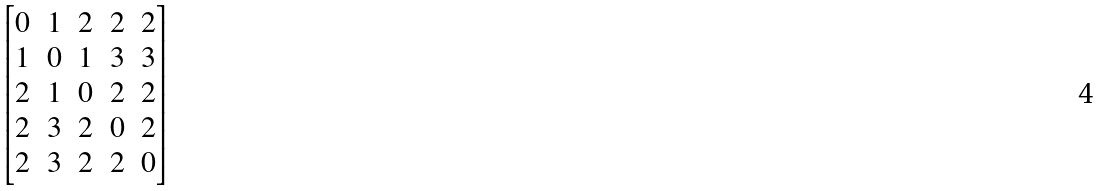<formula> <loc_0><loc_0><loc_500><loc_500>\begin{bmatrix} 0 & 1 & 2 & 2 & 2 \\ 1 & 0 & 1 & 3 & 3 \\ 2 & 1 & 0 & 2 & 2 \\ 2 & 3 & 2 & 0 & 2 \\ 2 & 3 & 2 & 2 & 0 \\ \end{bmatrix}</formula> 